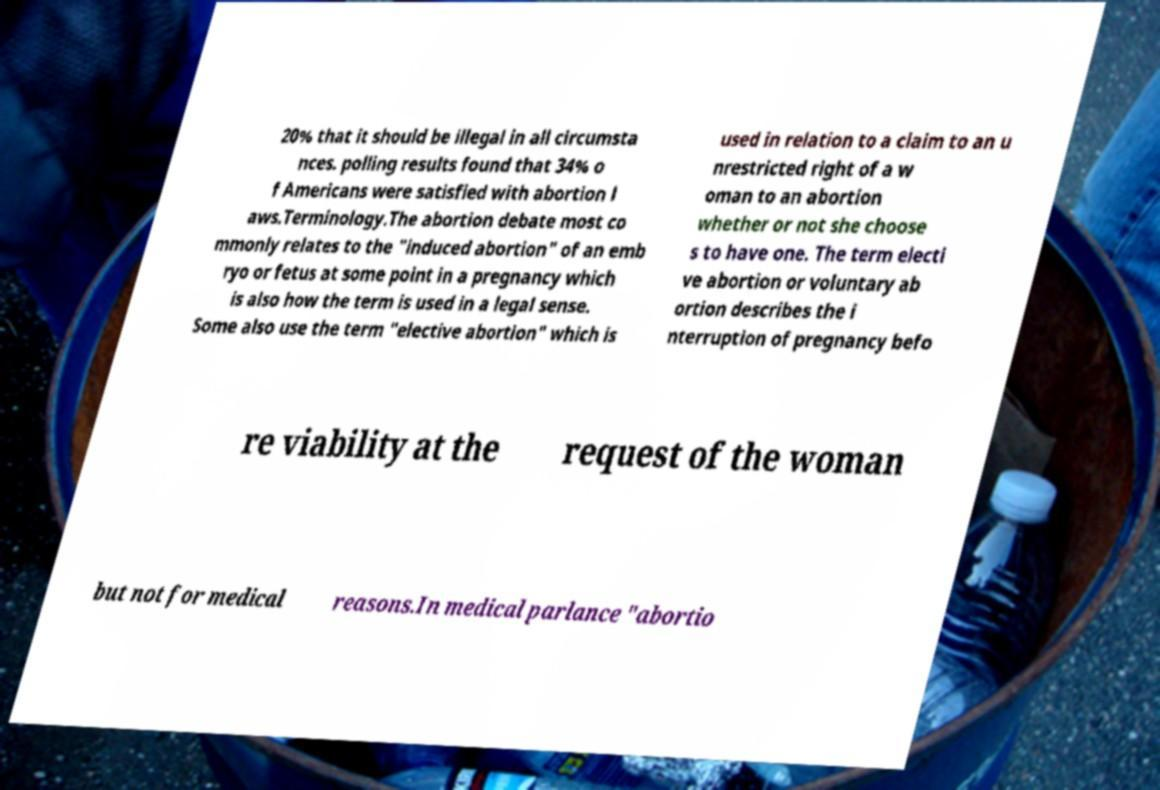For documentation purposes, I need the text within this image transcribed. Could you provide that? 20% that it should be illegal in all circumsta nces. polling results found that 34% o f Americans were satisfied with abortion l aws.Terminology.The abortion debate most co mmonly relates to the "induced abortion" of an emb ryo or fetus at some point in a pregnancy which is also how the term is used in a legal sense. Some also use the term "elective abortion" which is used in relation to a claim to an u nrestricted right of a w oman to an abortion whether or not she choose s to have one. The term electi ve abortion or voluntary ab ortion describes the i nterruption of pregnancy befo re viability at the request of the woman but not for medical reasons.In medical parlance "abortio 